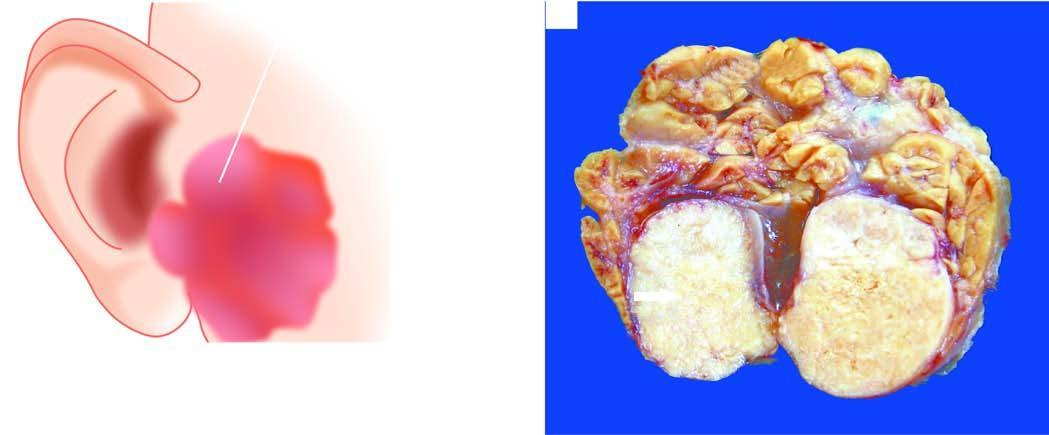does sectioned surface of the parotid gland show lobules of grey-white circumscribed tumour having semitranslucent parenchyma?
Answer the question using a single word or phrase. Yes 